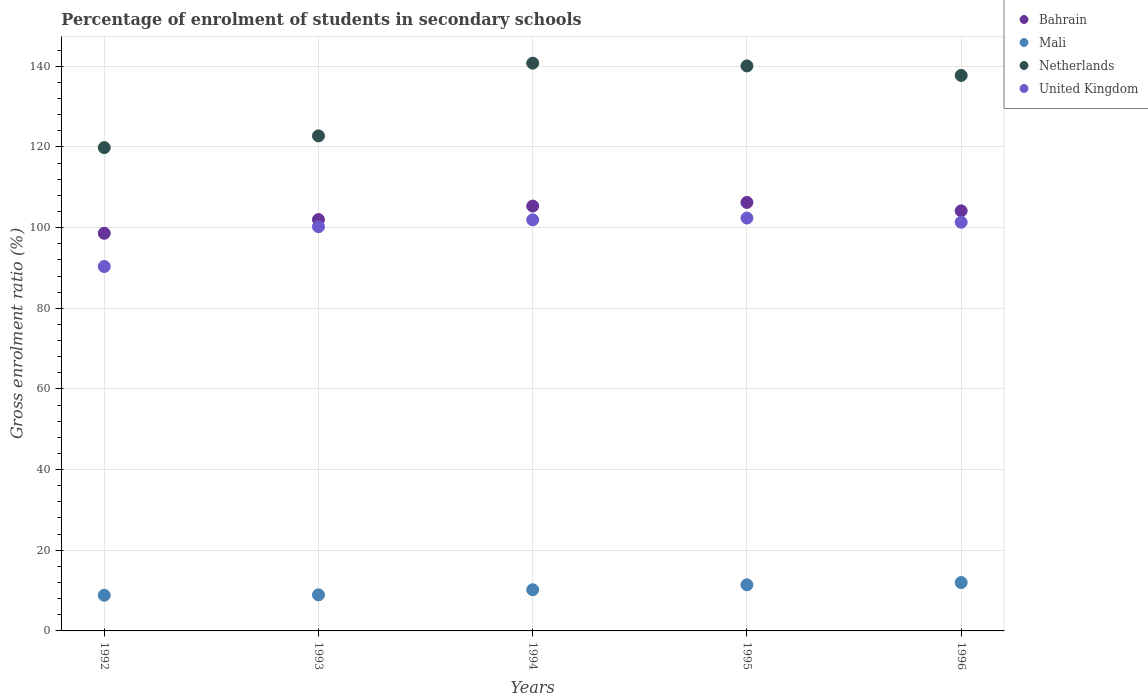How many different coloured dotlines are there?
Provide a short and direct response. 4. Is the number of dotlines equal to the number of legend labels?
Give a very brief answer. Yes. What is the percentage of students enrolled in secondary schools in Mali in 1994?
Offer a terse response. 10.21. Across all years, what is the maximum percentage of students enrolled in secondary schools in Mali?
Offer a terse response. 11.99. Across all years, what is the minimum percentage of students enrolled in secondary schools in Netherlands?
Give a very brief answer. 119.83. In which year was the percentage of students enrolled in secondary schools in United Kingdom minimum?
Keep it short and to the point. 1992. What is the total percentage of students enrolled in secondary schools in Mali in the graph?
Your answer should be compact. 51.43. What is the difference between the percentage of students enrolled in secondary schools in Mali in 1994 and that in 1996?
Your answer should be very brief. -1.78. What is the difference between the percentage of students enrolled in secondary schools in Netherlands in 1994 and the percentage of students enrolled in secondary schools in United Kingdom in 1996?
Keep it short and to the point. 39.44. What is the average percentage of students enrolled in secondary schools in Bahrain per year?
Your answer should be very brief. 103.27. In the year 1995, what is the difference between the percentage of students enrolled in secondary schools in Bahrain and percentage of students enrolled in secondary schools in Netherlands?
Provide a short and direct response. -33.85. In how many years, is the percentage of students enrolled in secondary schools in United Kingdom greater than 72 %?
Provide a succinct answer. 5. What is the ratio of the percentage of students enrolled in secondary schools in Bahrain in 1992 to that in 1993?
Provide a short and direct response. 0.97. What is the difference between the highest and the second highest percentage of students enrolled in secondary schools in United Kingdom?
Make the answer very short. 0.44. What is the difference between the highest and the lowest percentage of students enrolled in secondary schools in Mali?
Give a very brief answer. 3.15. Is the sum of the percentage of students enrolled in secondary schools in United Kingdom in 1992 and 1994 greater than the maximum percentage of students enrolled in secondary schools in Mali across all years?
Offer a very short reply. Yes. Is it the case that in every year, the sum of the percentage of students enrolled in secondary schools in Bahrain and percentage of students enrolled in secondary schools in Mali  is greater than the sum of percentage of students enrolled in secondary schools in United Kingdom and percentage of students enrolled in secondary schools in Netherlands?
Your response must be concise. No. Is the percentage of students enrolled in secondary schools in Netherlands strictly greater than the percentage of students enrolled in secondary schools in Bahrain over the years?
Keep it short and to the point. Yes. How many years are there in the graph?
Ensure brevity in your answer.  5. What is the difference between two consecutive major ticks on the Y-axis?
Your response must be concise. 20. Does the graph contain any zero values?
Ensure brevity in your answer.  No. Where does the legend appear in the graph?
Keep it short and to the point. Top right. How many legend labels are there?
Your answer should be very brief. 4. What is the title of the graph?
Make the answer very short. Percentage of enrolment of students in secondary schools. Does "Macedonia" appear as one of the legend labels in the graph?
Your answer should be compact. No. What is the label or title of the Y-axis?
Make the answer very short. Gross enrolment ratio (%). What is the Gross enrolment ratio (%) in Bahrain in 1992?
Provide a short and direct response. 98.59. What is the Gross enrolment ratio (%) of Mali in 1992?
Your answer should be compact. 8.85. What is the Gross enrolment ratio (%) of Netherlands in 1992?
Ensure brevity in your answer.  119.83. What is the Gross enrolment ratio (%) in United Kingdom in 1992?
Ensure brevity in your answer.  90.35. What is the Gross enrolment ratio (%) in Bahrain in 1993?
Offer a very short reply. 102. What is the Gross enrolment ratio (%) of Mali in 1993?
Provide a succinct answer. 8.95. What is the Gross enrolment ratio (%) in Netherlands in 1993?
Offer a very short reply. 122.74. What is the Gross enrolment ratio (%) of United Kingdom in 1993?
Your response must be concise. 100.22. What is the Gross enrolment ratio (%) of Bahrain in 1994?
Provide a short and direct response. 105.34. What is the Gross enrolment ratio (%) in Mali in 1994?
Make the answer very short. 10.21. What is the Gross enrolment ratio (%) of Netherlands in 1994?
Your response must be concise. 140.77. What is the Gross enrolment ratio (%) of United Kingdom in 1994?
Your answer should be very brief. 101.92. What is the Gross enrolment ratio (%) in Bahrain in 1995?
Keep it short and to the point. 106.24. What is the Gross enrolment ratio (%) in Mali in 1995?
Make the answer very short. 11.43. What is the Gross enrolment ratio (%) in Netherlands in 1995?
Provide a short and direct response. 140.09. What is the Gross enrolment ratio (%) in United Kingdom in 1995?
Offer a terse response. 102.37. What is the Gross enrolment ratio (%) of Bahrain in 1996?
Your answer should be very brief. 104.16. What is the Gross enrolment ratio (%) in Mali in 1996?
Provide a short and direct response. 11.99. What is the Gross enrolment ratio (%) of Netherlands in 1996?
Provide a short and direct response. 137.73. What is the Gross enrolment ratio (%) in United Kingdom in 1996?
Your response must be concise. 101.33. Across all years, what is the maximum Gross enrolment ratio (%) in Bahrain?
Offer a terse response. 106.24. Across all years, what is the maximum Gross enrolment ratio (%) of Mali?
Make the answer very short. 11.99. Across all years, what is the maximum Gross enrolment ratio (%) in Netherlands?
Keep it short and to the point. 140.77. Across all years, what is the maximum Gross enrolment ratio (%) in United Kingdom?
Offer a very short reply. 102.37. Across all years, what is the minimum Gross enrolment ratio (%) of Bahrain?
Provide a short and direct response. 98.59. Across all years, what is the minimum Gross enrolment ratio (%) in Mali?
Provide a succinct answer. 8.85. Across all years, what is the minimum Gross enrolment ratio (%) in Netherlands?
Give a very brief answer. 119.83. Across all years, what is the minimum Gross enrolment ratio (%) of United Kingdom?
Provide a succinct answer. 90.35. What is the total Gross enrolment ratio (%) in Bahrain in the graph?
Ensure brevity in your answer.  516.33. What is the total Gross enrolment ratio (%) in Mali in the graph?
Your answer should be very brief. 51.43. What is the total Gross enrolment ratio (%) of Netherlands in the graph?
Offer a very short reply. 661.16. What is the total Gross enrolment ratio (%) of United Kingdom in the graph?
Your response must be concise. 496.19. What is the difference between the Gross enrolment ratio (%) of Bahrain in 1992 and that in 1993?
Your answer should be compact. -3.4. What is the difference between the Gross enrolment ratio (%) of Mali in 1992 and that in 1993?
Offer a very short reply. -0.1. What is the difference between the Gross enrolment ratio (%) in Netherlands in 1992 and that in 1993?
Your answer should be compact. -2.91. What is the difference between the Gross enrolment ratio (%) in United Kingdom in 1992 and that in 1993?
Your answer should be very brief. -9.87. What is the difference between the Gross enrolment ratio (%) in Bahrain in 1992 and that in 1994?
Make the answer very short. -6.75. What is the difference between the Gross enrolment ratio (%) of Mali in 1992 and that in 1994?
Provide a short and direct response. -1.36. What is the difference between the Gross enrolment ratio (%) of Netherlands in 1992 and that in 1994?
Keep it short and to the point. -20.93. What is the difference between the Gross enrolment ratio (%) in United Kingdom in 1992 and that in 1994?
Make the answer very short. -11.57. What is the difference between the Gross enrolment ratio (%) of Bahrain in 1992 and that in 1995?
Your answer should be very brief. -7.64. What is the difference between the Gross enrolment ratio (%) in Mali in 1992 and that in 1995?
Offer a terse response. -2.58. What is the difference between the Gross enrolment ratio (%) in Netherlands in 1992 and that in 1995?
Provide a succinct answer. -20.25. What is the difference between the Gross enrolment ratio (%) in United Kingdom in 1992 and that in 1995?
Keep it short and to the point. -12.02. What is the difference between the Gross enrolment ratio (%) of Bahrain in 1992 and that in 1996?
Keep it short and to the point. -5.56. What is the difference between the Gross enrolment ratio (%) of Mali in 1992 and that in 1996?
Provide a succinct answer. -3.15. What is the difference between the Gross enrolment ratio (%) in Netherlands in 1992 and that in 1996?
Give a very brief answer. -17.9. What is the difference between the Gross enrolment ratio (%) in United Kingdom in 1992 and that in 1996?
Ensure brevity in your answer.  -10.98. What is the difference between the Gross enrolment ratio (%) in Bahrain in 1993 and that in 1994?
Offer a very short reply. -3.35. What is the difference between the Gross enrolment ratio (%) of Mali in 1993 and that in 1994?
Make the answer very short. -1.26. What is the difference between the Gross enrolment ratio (%) in Netherlands in 1993 and that in 1994?
Offer a very short reply. -18.03. What is the difference between the Gross enrolment ratio (%) of United Kingdom in 1993 and that in 1994?
Your answer should be compact. -1.7. What is the difference between the Gross enrolment ratio (%) of Bahrain in 1993 and that in 1995?
Provide a short and direct response. -4.24. What is the difference between the Gross enrolment ratio (%) of Mali in 1993 and that in 1995?
Provide a succinct answer. -2.48. What is the difference between the Gross enrolment ratio (%) in Netherlands in 1993 and that in 1995?
Offer a very short reply. -17.35. What is the difference between the Gross enrolment ratio (%) of United Kingdom in 1993 and that in 1995?
Provide a succinct answer. -2.15. What is the difference between the Gross enrolment ratio (%) of Bahrain in 1993 and that in 1996?
Give a very brief answer. -2.16. What is the difference between the Gross enrolment ratio (%) in Mali in 1993 and that in 1996?
Offer a very short reply. -3.04. What is the difference between the Gross enrolment ratio (%) of Netherlands in 1993 and that in 1996?
Offer a very short reply. -14.99. What is the difference between the Gross enrolment ratio (%) in United Kingdom in 1993 and that in 1996?
Ensure brevity in your answer.  -1.11. What is the difference between the Gross enrolment ratio (%) of Bahrain in 1994 and that in 1995?
Give a very brief answer. -0.9. What is the difference between the Gross enrolment ratio (%) in Mali in 1994 and that in 1995?
Give a very brief answer. -1.22. What is the difference between the Gross enrolment ratio (%) of Netherlands in 1994 and that in 1995?
Provide a short and direct response. 0.68. What is the difference between the Gross enrolment ratio (%) of United Kingdom in 1994 and that in 1995?
Give a very brief answer. -0.44. What is the difference between the Gross enrolment ratio (%) in Bahrain in 1994 and that in 1996?
Offer a very short reply. 1.19. What is the difference between the Gross enrolment ratio (%) of Mali in 1994 and that in 1996?
Make the answer very short. -1.78. What is the difference between the Gross enrolment ratio (%) in Netherlands in 1994 and that in 1996?
Your answer should be compact. 3.04. What is the difference between the Gross enrolment ratio (%) in United Kingdom in 1994 and that in 1996?
Offer a terse response. 0.59. What is the difference between the Gross enrolment ratio (%) in Bahrain in 1995 and that in 1996?
Make the answer very short. 2.08. What is the difference between the Gross enrolment ratio (%) of Mali in 1995 and that in 1996?
Ensure brevity in your answer.  -0.56. What is the difference between the Gross enrolment ratio (%) of Netherlands in 1995 and that in 1996?
Keep it short and to the point. 2.35. What is the difference between the Gross enrolment ratio (%) in United Kingdom in 1995 and that in 1996?
Give a very brief answer. 1.04. What is the difference between the Gross enrolment ratio (%) in Bahrain in 1992 and the Gross enrolment ratio (%) in Mali in 1993?
Give a very brief answer. 89.64. What is the difference between the Gross enrolment ratio (%) in Bahrain in 1992 and the Gross enrolment ratio (%) in Netherlands in 1993?
Make the answer very short. -24.15. What is the difference between the Gross enrolment ratio (%) in Bahrain in 1992 and the Gross enrolment ratio (%) in United Kingdom in 1993?
Your response must be concise. -1.62. What is the difference between the Gross enrolment ratio (%) in Mali in 1992 and the Gross enrolment ratio (%) in Netherlands in 1993?
Your answer should be very brief. -113.9. What is the difference between the Gross enrolment ratio (%) in Mali in 1992 and the Gross enrolment ratio (%) in United Kingdom in 1993?
Make the answer very short. -91.37. What is the difference between the Gross enrolment ratio (%) in Netherlands in 1992 and the Gross enrolment ratio (%) in United Kingdom in 1993?
Offer a terse response. 19.62. What is the difference between the Gross enrolment ratio (%) in Bahrain in 1992 and the Gross enrolment ratio (%) in Mali in 1994?
Your answer should be very brief. 88.38. What is the difference between the Gross enrolment ratio (%) in Bahrain in 1992 and the Gross enrolment ratio (%) in Netherlands in 1994?
Provide a succinct answer. -42.17. What is the difference between the Gross enrolment ratio (%) of Bahrain in 1992 and the Gross enrolment ratio (%) of United Kingdom in 1994?
Offer a very short reply. -3.33. What is the difference between the Gross enrolment ratio (%) in Mali in 1992 and the Gross enrolment ratio (%) in Netherlands in 1994?
Offer a terse response. -131.92. What is the difference between the Gross enrolment ratio (%) of Mali in 1992 and the Gross enrolment ratio (%) of United Kingdom in 1994?
Ensure brevity in your answer.  -93.08. What is the difference between the Gross enrolment ratio (%) of Netherlands in 1992 and the Gross enrolment ratio (%) of United Kingdom in 1994?
Your answer should be compact. 17.91. What is the difference between the Gross enrolment ratio (%) in Bahrain in 1992 and the Gross enrolment ratio (%) in Mali in 1995?
Offer a very short reply. 87.16. What is the difference between the Gross enrolment ratio (%) in Bahrain in 1992 and the Gross enrolment ratio (%) in Netherlands in 1995?
Ensure brevity in your answer.  -41.49. What is the difference between the Gross enrolment ratio (%) of Bahrain in 1992 and the Gross enrolment ratio (%) of United Kingdom in 1995?
Provide a succinct answer. -3.77. What is the difference between the Gross enrolment ratio (%) of Mali in 1992 and the Gross enrolment ratio (%) of Netherlands in 1995?
Ensure brevity in your answer.  -131.24. What is the difference between the Gross enrolment ratio (%) of Mali in 1992 and the Gross enrolment ratio (%) of United Kingdom in 1995?
Keep it short and to the point. -93.52. What is the difference between the Gross enrolment ratio (%) of Netherlands in 1992 and the Gross enrolment ratio (%) of United Kingdom in 1995?
Offer a very short reply. 17.47. What is the difference between the Gross enrolment ratio (%) in Bahrain in 1992 and the Gross enrolment ratio (%) in Mali in 1996?
Provide a short and direct response. 86.6. What is the difference between the Gross enrolment ratio (%) in Bahrain in 1992 and the Gross enrolment ratio (%) in Netherlands in 1996?
Ensure brevity in your answer.  -39.14. What is the difference between the Gross enrolment ratio (%) of Bahrain in 1992 and the Gross enrolment ratio (%) of United Kingdom in 1996?
Offer a terse response. -2.74. What is the difference between the Gross enrolment ratio (%) of Mali in 1992 and the Gross enrolment ratio (%) of Netherlands in 1996?
Keep it short and to the point. -128.89. What is the difference between the Gross enrolment ratio (%) in Mali in 1992 and the Gross enrolment ratio (%) in United Kingdom in 1996?
Provide a short and direct response. -92.49. What is the difference between the Gross enrolment ratio (%) of Netherlands in 1992 and the Gross enrolment ratio (%) of United Kingdom in 1996?
Give a very brief answer. 18.5. What is the difference between the Gross enrolment ratio (%) of Bahrain in 1993 and the Gross enrolment ratio (%) of Mali in 1994?
Make the answer very short. 91.79. What is the difference between the Gross enrolment ratio (%) in Bahrain in 1993 and the Gross enrolment ratio (%) in Netherlands in 1994?
Offer a terse response. -38.77. What is the difference between the Gross enrolment ratio (%) of Bahrain in 1993 and the Gross enrolment ratio (%) of United Kingdom in 1994?
Give a very brief answer. 0.07. What is the difference between the Gross enrolment ratio (%) in Mali in 1993 and the Gross enrolment ratio (%) in Netherlands in 1994?
Provide a succinct answer. -131.82. What is the difference between the Gross enrolment ratio (%) of Mali in 1993 and the Gross enrolment ratio (%) of United Kingdom in 1994?
Your response must be concise. -92.97. What is the difference between the Gross enrolment ratio (%) in Netherlands in 1993 and the Gross enrolment ratio (%) in United Kingdom in 1994?
Ensure brevity in your answer.  20.82. What is the difference between the Gross enrolment ratio (%) in Bahrain in 1993 and the Gross enrolment ratio (%) in Mali in 1995?
Offer a terse response. 90.57. What is the difference between the Gross enrolment ratio (%) of Bahrain in 1993 and the Gross enrolment ratio (%) of Netherlands in 1995?
Provide a short and direct response. -38.09. What is the difference between the Gross enrolment ratio (%) in Bahrain in 1993 and the Gross enrolment ratio (%) in United Kingdom in 1995?
Your response must be concise. -0.37. What is the difference between the Gross enrolment ratio (%) in Mali in 1993 and the Gross enrolment ratio (%) in Netherlands in 1995?
Offer a very short reply. -131.14. What is the difference between the Gross enrolment ratio (%) of Mali in 1993 and the Gross enrolment ratio (%) of United Kingdom in 1995?
Make the answer very short. -93.42. What is the difference between the Gross enrolment ratio (%) in Netherlands in 1993 and the Gross enrolment ratio (%) in United Kingdom in 1995?
Your answer should be very brief. 20.37. What is the difference between the Gross enrolment ratio (%) in Bahrain in 1993 and the Gross enrolment ratio (%) in Mali in 1996?
Offer a very short reply. 90. What is the difference between the Gross enrolment ratio (%) in Bahrain in 1993 and the Gross enrolment ratio (%) in Netherlands in 1996?
Your answer should be compact. -35.74. What is the difference between the Gross enrolment ratio (%) of Bahrain in 1993 and the Gross enrolment ratio (%) of United Kingdom in 1996?
Give a very brief answer. 0.66. What is the difference between the Gross enrolment ratio (%) of Mali in 1993 and the Gross enrolment ratio (%) of Netherlands in 1996?
Offer a terse response. -128.78. What is the difference between the Gross enrolment ratio (%) in Mali in 1993 and the Gross enrolment ratio (%) in United Kingdom in 1996?
Your response must be concise. -92.38. What is the difference between the Gross enrolment ratio (%) in Netherlands in 1993 and the Gross enrolment ratio (%) in United Kingdom in 1996?
Ensure brevity in your answer.  21.41. What is the difference between the Gross enrolment ratio (%) in Bahrain in 1994 and the Gross enrolment ratio (%) in Mali in 1995?
Your response must be concise. 93.91. What is the difference between the Gross enrolment ratio (%) in Bahrain in 1994 and the Gross enrolment ratio (%) in Netherlands in 1995?
Ensure brevity in your answer.  -34.74. What is the difference between the Gross enrolment ratio (%) of Bahrain in 1994 and the Gross enrolment ratio (%) of United Kingdom in 1995?
Give a very brief answer. 2.97. What is the difference between the Gross enrolment ratio (%) of Mali in 1994 and the Gross enrolment ratio (%) of Netherlands in 1995?
Provide a succinct answer. -129.88. What is the difference between the Gross enrolment ratio (%) of Mali in 1994 and the Gross enrolment ratio (%) of United Kingdom in 1995?
Ensure brevity in your answer.  -92.16. What is the difference between the Gross enrolment ratio (%) in Netherlands in 1994 and the Gross enrolment ratio (%) in United Kingdom in 1995?
Offer a terse response. 38.4. What is the difference between the Gross enrolment ratio (%) of Bahrain in 1994 and the Gross enrolment ratio (%) of Mali in 1996?
Give a very brief answer. 93.35. What is the difference between the Gross enrolment ratio (%) of Bahrain in 1994 and the Gross enrolment ratio (%) of Netherlands in 1996?
Offer a very short reply. -32.39. What is the difference between the Gross enrolment ratio (%) of Bahrain in 1994 and the Gross enrolment ratio (%) of United Kingdom in 1996?
Ensure brevity in your answer.  4.01. What is the difference between the Gross enrolment ratio (%) in Mali in 1994 and the Gross enrolment ratio (%) in Netherlands in 1996?
Your answer should be compact. -127.52. What is the difference between the Gross enrolment ratio (%) of Mali in 1994 and the Gross enrolment ratio (%) of United Kingdom in 1996?
Offer a very short reply. -91.12. What is the difference between the Gross enrolment ratio (%) in Netherlands in 1994 and the Gross enrolment ratio (%) in United Kingdom in 1996?
Your answer should be compact. 39.44. What is the difference between the Gross enrolment ratio (%) of Bahrain in 1995 and the Gross enrolment ratio (%) of Mali in 1996?
Keep it short and to the point. 94.25. What is the difference between the Gross enrolment ratio (%) in Bahrain in 1995 and the Gross enrolment ratio (%) in Netherlands in 1996?
Make the answer very short. -31.49. What is the difference between the Gross enrolment ratio (%) of Bahrain in 1995 and the Gross enrolment ratio (%) of United Kingdom in 1996?
Your answer should be compact. 4.91. What is the difference between the Gross enrolment ratio (%) in Mali in 1995 and the Gross enrolment ratio (%) in Netherlands in 1996?
Provide a short and direct response. -126.3. What is the difference between the Gross enrolment ratio (%) of Mali in 1995 and the Gross enrolment ratio (%) of United Kingdom in 1996?
Provide a succinct answer. -89.9. What is the difference between the Gross enrolment ratio (%) of Netherlands in 1995 and the Gross enrolment ratio (%) of United Kingdom in 1996?
Your response must be concise. 38.75. What is the average Gross enrolment ratio (%) in Bahrain per year?
Make the answer very short. 103.27. What is the average Gross enrolment ratio (%) in Mali per year?
Make the answer very short. 10.29. What is the average Gross enrolment ratio (%) in Netherlands per year?
Ensure brevity in your answer.  132.23. What is the average Gross enrolment ratio (%) of United Kingdom per year?
Keep it short and to the point. 99.24. In the year 1992, what is the difference between the Gross enrolment ratio (%) of Bahrain and Gross enrolment ratio (%) of Mali?
Ensure brevity in your answer.  89.75. In the year 1992, what is the difference between the Gross enrolment ratio (%) of Bahrain and Gross enrolment ratio (%) of Netherlands?
Offer a terse response. -21.24. In the year 1992, what is the difference between the Gross enrolment ratio (%) of Bahrain and Gross enrolment ratio (%) of United Kingdom?
Keep it short and to the point. 8.24. In the year 1992, what is the difference between the Gross enrolment ratio (%) in Mali and Gross enrolment ratio (%) in Netherlands?
Your answer should be very brief. -110.99. In the year 1992, what is the difference between the Gross enrolment ratio (%) in Mali and Gross enrolment ratio (%) in United Kingdom?
Ensure brevity in your answer.  -81.51. In the year 1992, what is the difference between the Gross enrolment ratio (%) of Netherlands and Gross enrolment ratio (%) of United Kingdom?
Keep it short and to the point. 29.48. In the year 1993, what is the difference between the Gross enrolment ratio (%) in Bahrain and Gross enrolment ratio (%) in Mali?
Your answer should be compact. 93.05. In the year 1993, what is the difference between the Gross enrolment ratio (%) of Bahrain and Gross enrolment ratio (%) of Netherlands?
Keep it short and to the point. -20.74. In the year 1993, what is the difference between the Gross enrolment ratio (%) of Bahrain and Gross enrolment ratio (%) of United Kingdom?
Keep it short and to the point. 1.78. In the year 1993, what is the difference between the Gross enrolment ratio (%) of Mali and Gross enrolment ratio (%) of Netherlands?
Provide a short and direct response. -113.79. In the year 1993, what is the difference between the Gross enrolment ratio (%) in Mali and Gross enrolment ratio (%) in United Kingdom?
Make the answer very short. -91.27. In the year 1993, what is the difference between the Gross enrolment ratio (%) in Netherlands and Gross enrolment ratio (%) in United Kingdom?
Your answer should be compact. 22.52. In the year 1994, what is the difference between the Gross enrolment ratio (%) of Bahrain and Gross enrolment ratio (%) of Mali?
Provide a short and direct response. 95.13. In the year 1994, what is the difference between the Gross enrolment ratio (%) of Bahrain and Gross enrolment ratio (%) of Netherlands?
Your answer should be very brief. -35.43. In the year 1994, what is the difference between the Gross enrolment ratio (%) in Bahrain and Gross enrolment ratio (%) in United Kingdom?
Keep it short and to the point. 3.42. In the year 1994, what is the difference between the Gross enrolment ratio (%) in Mali and Gross enrolment ratio (%) in Netherlands?
Offer a terse response. -130.56. In the year 1994, what is the difference between the Gross enrolment ratio (%) of Mali and Gross enrolment ratio (%) of United Kingdom?
Offer a very short reply. -91.71. In the year 1994, what is the difference between the Gross enrolment ratio (%) of Netherlands and Gross enrolment ratio (%) of United Kingdom?
Provide a short and direct response. 38.85. In the year 1995, what is the difference between the Gross enrolment ratio (%) of Bahrain and Gross enrolment ratio (%) of Mali?
Offer a very short reply. 94.81. In the year 1995, what is the difference between the Gross enrolment ratio (%) of Bahrain and Gross enrolment ratio (%) of Netherlands?
Ensure brevity in your answer.  -33.85. In the year 1995, what is the difference between the Gross enrolment ratio (%) in Bahrain and Gross enrolment ratio (%) in United Kingdom?
Offer a terse response. 3.87. In the year 1995, what is the difference between the Gross enrolment ratio (%) of Mali and Gross enrolment ratio (%) of Netherlands?
Your answer should be compact. -128.66. In the year 1995, what is the difference between the Gross enrolment ratio (%) of Mali and Gross enrolment ratio (%) of United Kingdom?
Offer a very short reply. -90.94. In the year 1995, what is the difference between the Gross enrolment ratio (%) in Netherlands and Gross enrolment ratio (%) in United Kingdom?
Keep it short and to the point. 37.72. In the year 1996, what is the difference between the Gross enrolment ratio (%) of Bahrain and Gross enrolment ratio (%) of Mali?
Offer a very short reply. 92.16. In the year 1996, what is the difference between the Gross enrolment ratio (%) in Bahrain and Gross enrolment ratio (%) in Netherlands?
Ensure brevity in your answer.  -33.58. In the year 1996, what is the difference between the Gross enrolment ratio (%) of Bahrain and Gross enrolment ratio (%) of United Kingdom?
Keep it short and to the point. 2.82. In the year 1996, what is the difference between the Gross enrolment ratio (%) of Mali and Gross enrolment ratio (%) of Netherlands?
Offer a terse response. -125.74. In the year 1996, what is the difference between the Gross enrolment ratio (%) in Mali and Gross enrolment ratio (%) in United Kingdom?
Offer a very short reply. -89.34. In the year 1996, what is the difference between the Gross enrolment ratio (%) in Netherlands and Gross enrolment ratio (%) in United Kingdom?
Offer a terse response. 36.4. What is the ratio of the Gross enrolment ratio (%) in Bahrain in 1992 to that in 1993?
Ensure brevity in your answer.  0.97. What is the ratio of the Gross enrolment ratio (%) of Mali in 1992 to that in 1993?
Your answer should be very brief. 0.99. What is the ratio of the Gross enrolment ratio (%) in Netherlands in 1992 to that in 1993?
Provide a short and direct response. 0.98. What is the ratio of the Gross enrolment ratio (%) in United Kingdom in 1992 to that in 1993?
Give a very brief answer. 0.9. What is the ratio of the Gross enrolment ratio (%) of Bahrain in 1992 to that in 1994?
Provide a short and direct response. 0.94. What is the ratio of the Gross enrolment ratio (%) of Mali in 1992 to that in 1994?
Offer a terse response. 0.87. What is the ratio of the Gross enrolment ratio (%) of Netherlands in 1992 to that in 1994?
Provide a short and direct response. 0.85. What is the ratio of the Gross enrolment ratio (%) in United Kingdom in 1992 to that in 1994?
Your answer should be very brief. 0.89. What is the ratio of the Gross enrolment ratio (%) in Bahrain in 1992 to that in 1995?
Make the answer very short. 0.93. What is the ratio of the Gross enrolment ratio (%) in Mali in 1992 to that in 1995?
Give a very brief answer. 0.77. What is the ratio of the Gross enrolment ratio (%) in Netherlands in 1992 to that in 1995?
Make the answer very short. 0.86. What is the ratio of the Gross enrolment ratio (%) of United Kingdom in 1992 to that in 1995?
Offer a very short reply. 0.88. What is the ratio of the Gross enrolment ratio (%) in Bahrain in 1992 to that in 1996?
Your response must be concise. 0.95. What is the ratio of the Gross enrolment ratio (%) in Mali in 1992 to that in 1996?
Ensure brevity in your answer.  0.74. What is the ratio of the Gross enrolment ratio (%) in Netherlands in 1992 to that in 1996?
Your answer should be very brief. 0.87. What is the ratio of the Gross enrolment ratio (%) of United Kingdom in 1992 to that in 1996?
Provide a short and direct response. 0.89. What is the ratio of the Gross enrolment ratio (%) of Bahrain in 1993 to that in 1994?
Make the answer very short. 0.97. What is the ratio of the Gross enrolment ratio (%) in Mali in 1993 to that in 1994?
Provide a succinct answer. 0.88. What is the ratio of the Gross enrolment ratio (%) in Netherlands in 1993 to that in 1994?
Your answer should be compact. 0.87. What is the ratio of the Gross enrolment ratio (%) in United Kingdom in 1993 to that in 1994?
Provide a succinct answer. 0.98. What is the ratio of the Gross enrolment ratio (%) of Bahrain in 1993 to that in 1995?
Keep it short and to the point. 0.96. What is the ratio of the Gross enrolment ratio (%) in Mali in 1993 to that in 1995?
Your answer should be compact. 0.78. What is the ratio of the Gross enrolment ratio (%) in Netherlands in 1993 to that in 1995?
Give a very brief answer. 0.88. What is the ratio of the Gross enrolment ratio (%) of United Kingdom in 1993 to that in 1995?
Your answer should be compact. 0.98. What is the ratio of the Gross enrolment ratio (%) in Bahrain in 1993 to that in 1996?
Provide a short and direct response. 0.98. What is the ratio of the Gross enrolment ratio (%) of Mali in 1993 to that in 1996?
Offer a terse response. 0.75. What is the ratio of the Gross enrolment ratio (%) of Netherlands in 1993 to that in 1996?
Make the answer very short. 0.89. What is the ratio of the Gross enrolment ratio (%) in United Kingdom in 1993 to that in 1996?
Provide a short and direct response. 0.99. What is the ratio of the Gross enrolment ratio (%) in Bahrain in 1994 to that in 1995?
Offer a very short reply. 0.99. What is the ratio of the Gross enrolment ratio (%) in Mali in 1994 to that in 1995?
Offer a very short reply. 0.89. What is the ratio of the Gross enrolment ratio (%) of Netherlands in 1994 to that in 1995?
Offer a terse response. 1. What is the ratio of the Gross enrolment ratio (%) of Bahrain in 1994 to that in 1996?
Offer a very short reply. 1.01. What is the ratio of the Gross enrolment ratio (%) in Mali in 1994 to that in 1996?
Your answer should be compact. 0.85. What is the ratio of the Gross enrolment ratio (%) of Netherlands in 1994 to that in 1996?
Provide a short and direct response. 1.02. What is the ratio of the Gross enrolment ratio (%) in Bahrain in 1995 to that in 1996?
Give a very brief answer. 1.02. What is the ratio of the Gross enrolment ratio (%) in Mali in 1995 to that in 1996?
Your response must be concise. 0.95. What is the ratio of the Gross enrolment ratio (%) in Netherlands in 1995 to that in 1996?
Offer a terse response. 1.02. What is the ratio of the Gross enrolment ratio (%) in United Kingdom in 1995 to that in 1996?
Your response must be concise. 1.01. What is the difference between the highest and the second highest Gross enrolment ratio (%) of Bahrain?
Provide a short and direct response. 0.9. What is the difference between the highest and the second highest Gross enrolment ratio (%) of Mali?
Your response must be concise. 0.56. What is the difference between the highest and the second highest Gross enrolment ratio (%) in Netherlands?
Your answer should be very brief. 0.68. What is the difference between the highest and the second highest Gross enrolment ratio (%) in United Kingdom?
Provide a short and direct response. 0.44. What is the difference between the highest and the lowest Gross enrolment ratio (%) in Bahrain?
Your answer should be very brief. 7.64. What is the difference between the highest and the lowest Gross enrolment ratio (%) of Mali?
Offer a very short reply. 3.15. What is the difference between the highest and the lowest Gross enrolment ratio (%) in Netherlands?
Your response must be concise. 20.93. What is the difference between the highest and the lowest Gross enrolment ratio (%) of United Kingdom?
Keep it short and to the point. 12.02. 